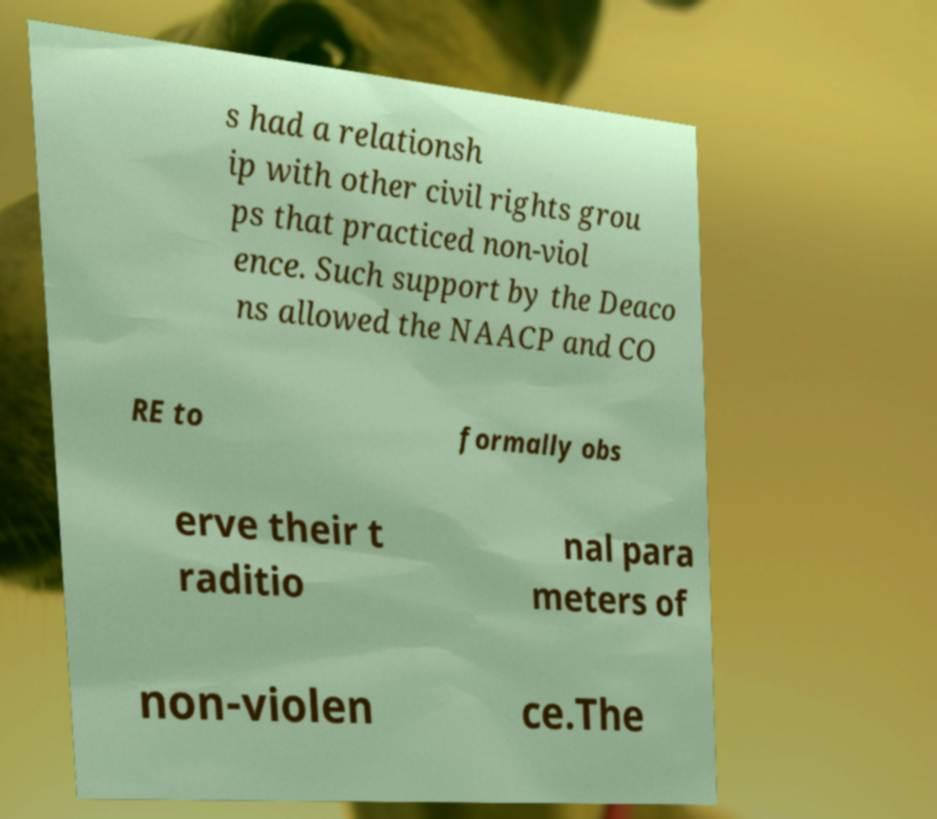Can you accurately transcribe the text from the provided image for me? s had a relationsh ip with other civil rights grou ps that practiced non-viol ence. Such support by the Deaco ns allowed the NAACP and CO RE to formally obs erve their t raditio nal para meters of non-violen ce.The 